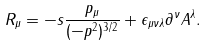<formula> <loc_0><loc_0><loc_500><loc_500>R _ { \mu } = - s \frac { p _ { \mu } } { ( - p ^ { 2 } ) ^ { 3 / 2 } } + \epsilon _ { \mu \nu \lambda } \partial ^ { \nu } A ^ { \lambda } .</formula> 